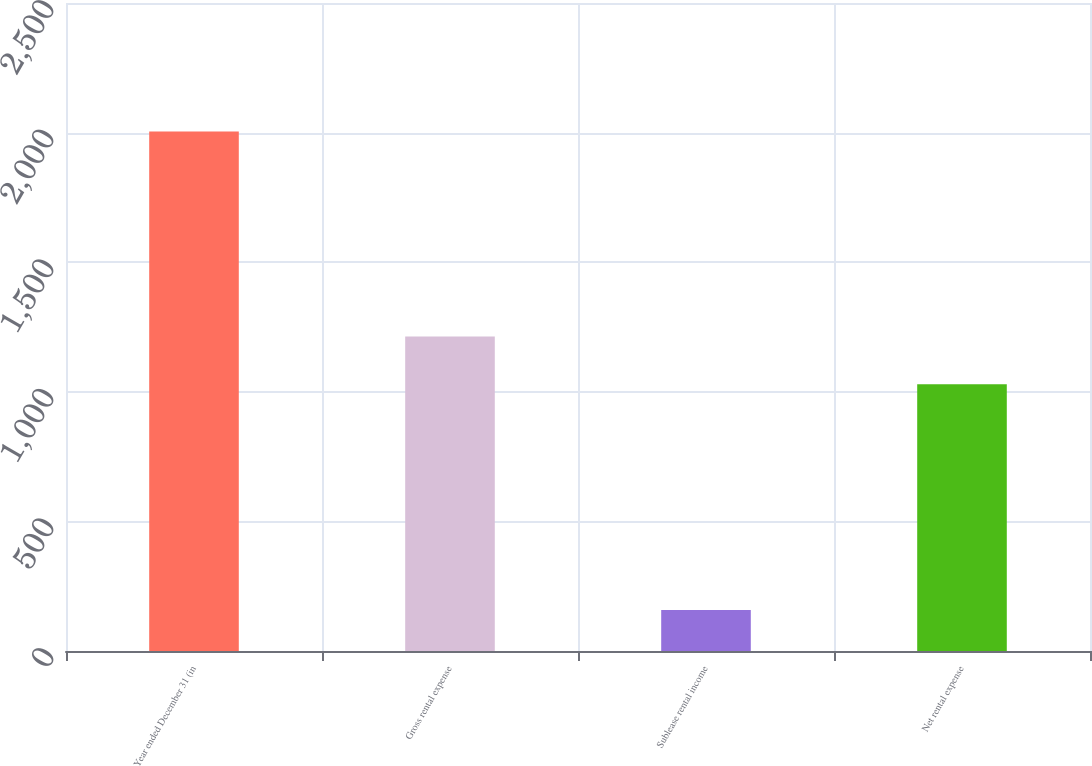<chart> <loc_0><loc_0><loc_500><loc_500><bar_chart><fcel>Year ended December 31 (in<fcel>Gross rental expense<fcel>Sublease rental income<fcel>Net rental expense<nl><fcel>2004<fcel>1213.6<fcel>158<fcel>1029<nl></chart> 